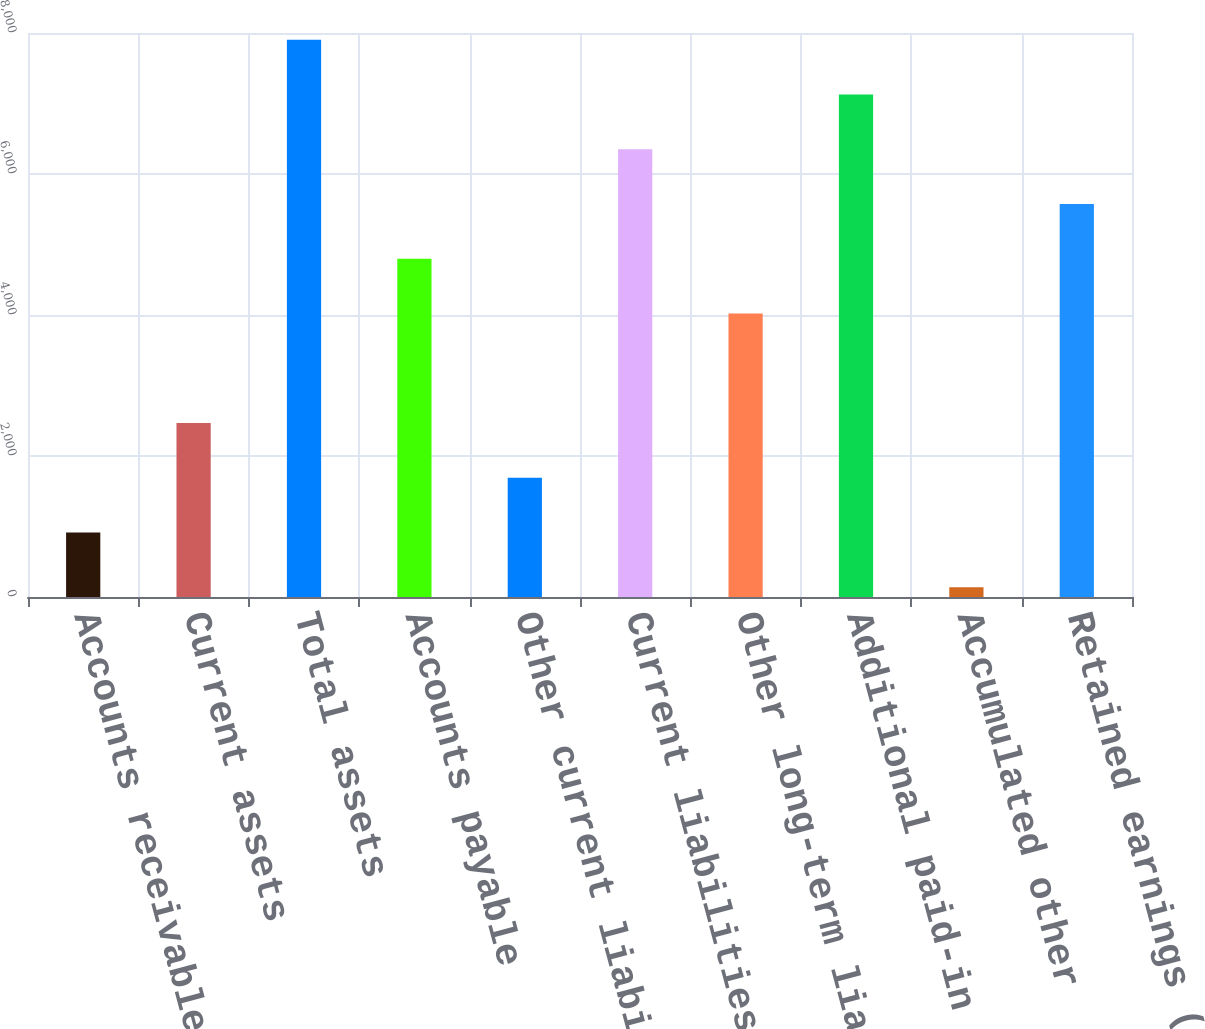Convert chart to OTSL. <chart><loc_0><loc_0><loc_500><loc_500><bar_chart><fcel>Accounts receivable<fcel>Current assets<fcel>Total assets<fcel>Accounts payable<fcel>Other current liabilities<fcel>Current liabilities<fcel>Other long-term liabilities<fcel>Additional paid-in capital<fcel>Accumulated other<fcel>Retained earnings (deficit)<nl><fcel>914.8<fcel>2468.4<fcel>7906<fcel>4798.8<fcel>1691.6<fcel>6352.4<fcel>4022<fcel>7129.2<fcel>138<fcel>5575.6<nl></chart> 